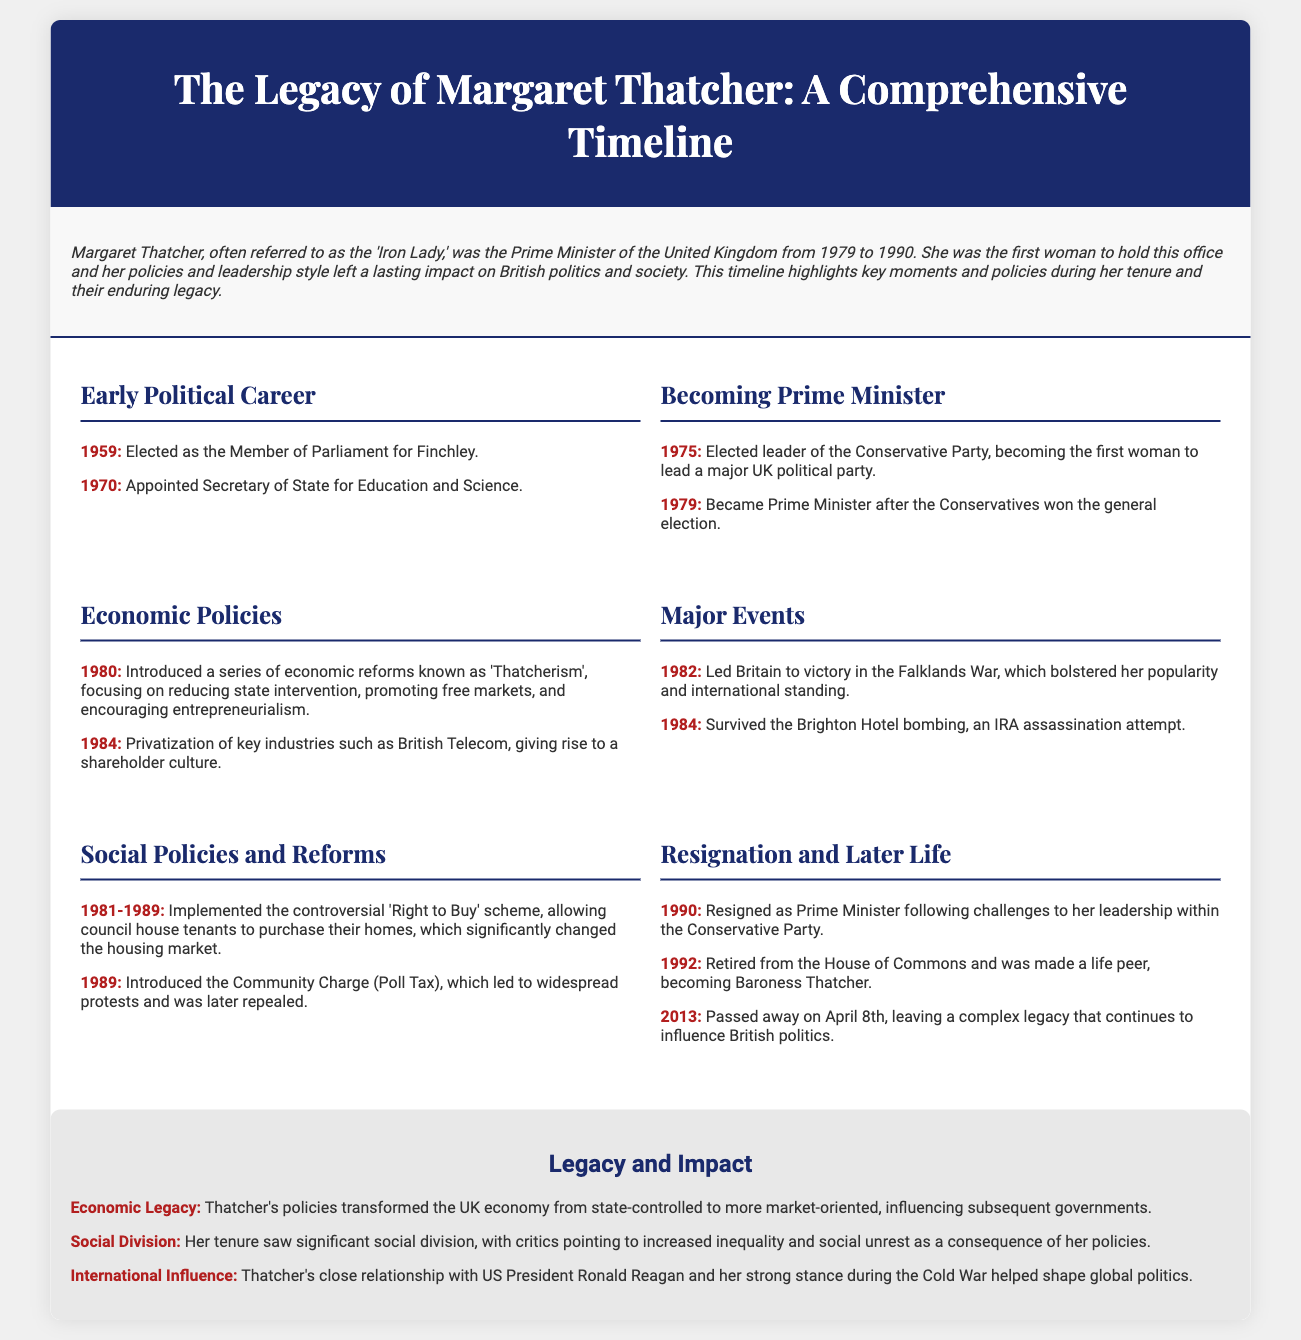what year did Margaret Thatcher become Prime Minister? This information is found in the "Becoming Prime Minister" section of the document, stating she became Prime Minister in 1979.
Answer: 1979 what was the 'Right to Buy' scheme? The document outlines this scheme in the "Social Policies and Reforms" section, indicating it allowed council house tenants to purchase their homes.
Answer: Allowed council house tenants to purchase their homes which war did Margaret Thatcher lead Britain to victory in? The document identifies this significant event in the "Major Events" section, stating it was the Falklands War in 1982.
Answer: Falklands War what year did Thatcher resign as Prime Minister? The document indicates her resignation was in 1990, specifically in the "Resignation and Later Life" section.
Answer: 1990 who did Margaret Thatcher have a close relationship with during the Cold War? The document mentions her close relationship with Ronald Reagan in the "Legacy and Impact" section.
Answer: Ronald Reagan what economic reforms are associated with Thatcher's policies? The document refers to these reforms in the "Economic Policies" section, describing them as 'Thatcherism'.
Answer: 'Thatcherism' how did Margaret Thatcher impact social division in Britain? The document discusses the criticism of her policies regarding social division, emphasizing increased inequality and unrest in the "Legacy and Impact" section.
Answer: Increased inequality and social unrest when did Margaret Thatcher pass away? This detail is contained in the "Resignation and Later Life" section, specifying her passing in 2013.
Answer: 2013 what title was Margaret Thatcher given after retiring from the House of Commons? The document states in the "Resignation and Later Life" section that she became Baroness Thatcher.
Answer: Baroness Thatcher 